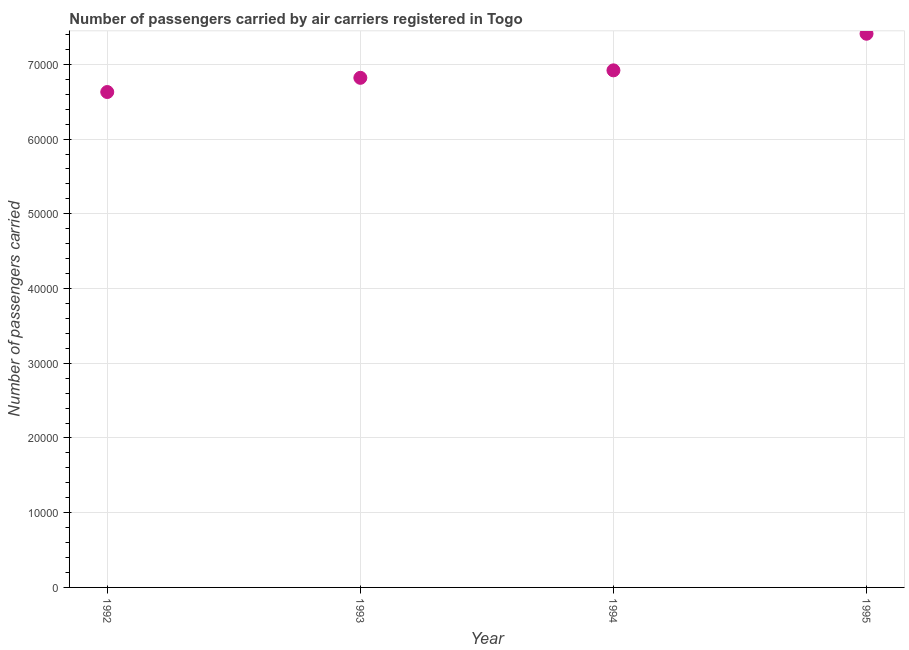What is the number of passengers carried in 1992?
Your answer should be compact. 6.63e+04. Across all years, what is the maximum number of passengers carried?
Offer a very short reply. 7.41e+04. Across all years, what is the minimum number of passengers carried?
Provide a succinct answer. 6.63e+04. In which year was the number of passengers carried maximum?
Your answer should be very brief. 1995. In which year was the number of passengers carried minimum?
Keep it short and to the point. 1992. What is the sum of the number of passengers carried?
Offer a very short reply. 2.78e+05. What is the difference between the number of passengers carried in 1993 and 1994?
Provide a short and direct response. -1000. What is the average number of passengers carried per year?
Make the answer very short. 6.94e+04. What is the median number of passengers carried?
Ensure brevity in your answer.  6.87e+04. What is the ratio of the number of passengers carried in 1992 to that in 1995?
Make the answer very short. 0.89. What is the difference between the highest and the second highest number of passengers carried?
Give a very brief answer. 4900. What is the difference between the highest and the lowest number of passengers carried?
Give a very brief answer. 7800. In how many years, is the number of passengers carried greater than the average number of passengers carried taken over all years?
Your response must be concise. 1. Does the number of passengers carried monotonically increase over the years?
Your answer should be compact. Yes. How many dotlines are there?
Provide a short and direct response. 1. How many years are there in the graph?
Give a very brief answer. 4. Are the values on the major ticks of Y-axis written in scientific E-notation?
Provide a short and direct response. No. Does the graph contain any zero values?
Keep it short and to the point. No. Does the graph contain grids?
Offer a very short reply. Yes. What is the title of the graph?
Offer a very short reply. Number of passengers carried by air carriers registered in Togo. What is the label or title of the X-axis?
Offer a very short reply. Year. What is the label or title of the Y-axis?
Provide a short and direct response. Number of passengers carried. What is the Number of passengers carried in 1992?
Your answer should be compact. 6.63e+04. What is the Number of passengers carried in 1993?
Make the answer very short. 6.82e+04. What is the Number of passengers carried in 1994?
Your response must be concise. 6.92e+04. What is the Number of passengers carried in 1995?
Make the answer very short. 7.41e+04. What is the difference between the Number of passengers carried in 1992 and 1993?
Your answer should be compact. -1900. What is the difference between the Number of passengers carried in 1992 and 1994?
Give a very brief answer. -2900. What is the difference between the Number of passengers carried in 1992 and 1995?
Make the answer very short. -7800. What is the difference between the Number of passengers carried in 1993 and 1994?
Your answer should be very brief. -1000. What is the difference between the Number of passengers carried in 1993 and 1995?
Offer a terse response. -5900. What is the difference between the Number of passengers carried in 1994 and 1995?
Make the answer very short. -4900. What is the ratio of the Number of passengers carried in 1992 to that in 1993?
Provide a short and direct response. 0.97. What is the ratio of the Number of passengers carried in 1992 to that in 1994?
Provide a short and direct response. 0.96. What is the ratio of the Number of passengers carried in 1992 to that in 1995?
Give a very brief answer. 0.9. What is the ratio of the Number of passengers carried in 1994 to that in 1995?
Keep it short and to the point. 0.93. 